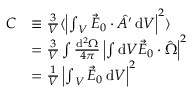Convert formula to latex. <formula><loc_0><loc_0><loc_500><loc_500>\begin{array} { r l } { C } & { \equiv \frac { 3 } { V } \langle \left | { \int } _ { V } \, \vec { E } _ { 0 } \cdot \hat { A ^ { \prime } } \, d V \right | ^ { 2 } \rangle } \\ & { = \frac { 3 } { V } \int \frac { d ^ { 2 } \Omega } { 4 \pi } \left | \int d V \vec { E } _ { 0 } \cdot \hat { \Omega } \right | ^ { 2 } } \\ & { = \frac { 1 } { V } \left | { \int } _ { V } \, \vec { E } _ { 0 } \, d V \right | ^ { 2 } } \end{array}</formula> 